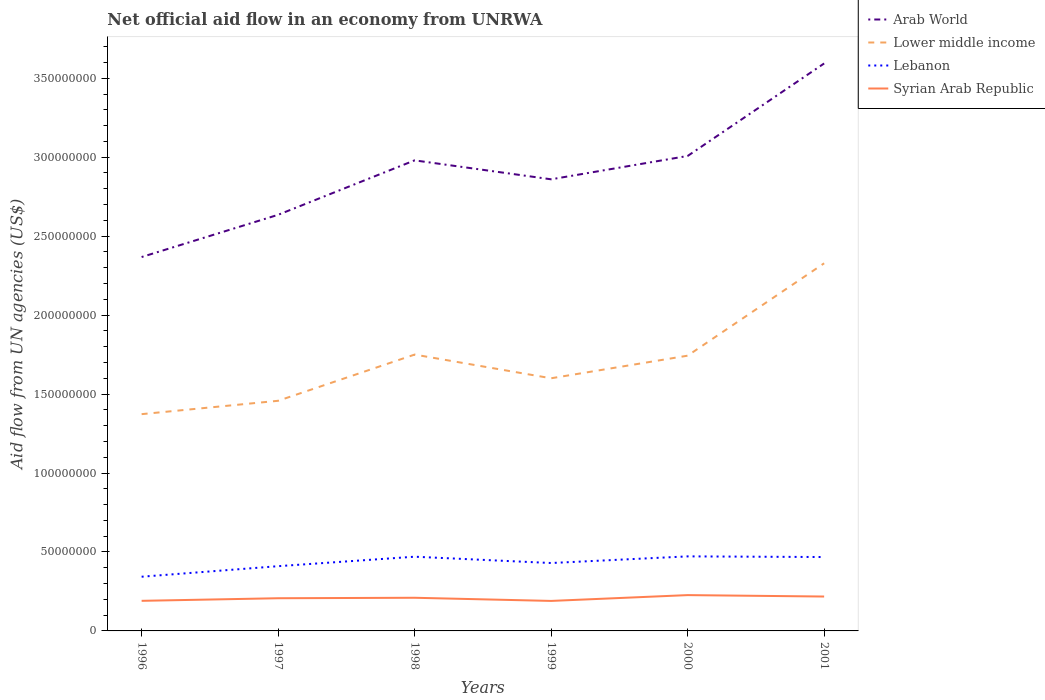How many different coloured lines are there?
Give a very brief answer. 4. Across all years, what is the maximum net official aid flow in Syrian Arab Republic?
Offer a terse response. 1.90e+07. In which year was the net official aid flow in Lower middle income maximum?
Offer a terse response. 1996. What is the total net official aid flow in Arab World in the graph?
Provide a short and direct response. -7.34e+07. What is the difference between the highest and the second highest net official aid flow in Lebanon?
Provide a succinct answer. 1.29e+07. What is the difference between the highest and the lowest net official aid flow in Syrian Arab Republic?
Provide a short and direct response. 3. Does the graph contain any zero values?
Provide a succinct answer. No. Does the graph contain grids?
Offer a terse response. No. How are the legend labels stacked?
Ensure brevity in your answer.  Vertical. What is the title of the graph?
Offer a very short reply. Net official aid flow in an economy from UNRWA. Does "Least developed countries" appear as one of the legend labels in the graph?
Your answer should be compact. No. What is the label or title of the Y-axis?
Offer a very short reply. Aid flow from UN agencies (US$). What is the Aid flow from UN agencies (US$) of Arab World in 1996?
Your answer should be compact. 2.37e+08. What is the Aid flow from UN agencies (US$) in Lower middle income in 1996?
Ensure brevity in your answer.  1.37e+08. What is the Aid flow from UN agencies (US$) of Lebanon in 1996?
Your answer should be compact. 3.43e+07. What is the Aid flow from UN agencies (US$) in Syrian Arab Republic in 1996?
Provide a succinct answer. 1.91e+07. What is the Aid flow from UN agencies (US$) of Arab World in 1997?
Offer a very short reply. 2.64e+08. What is the Aid flow from UN agencies (US$) of Lower middle income in 1997?
Your answer should be very brief. 1.46e+08. What is the Aid flow from UN agencies (US$) in Lebanon in 1997?
Keep it short and to the point. 4.10e+07. What is the Aid flow from UN agencies (US$) in Syrian Arab Republic in 1997?
Your response must be concise. 2.07e+07. What is the Aid flow from UN agencies (US$) of Arab World in 1998?
Your response must be concise. 2.98e+08. What is the Aid flow from UN agencies (US$) in Lower middle income in 1998?
Give a very brief answer. 1.75e+08. What is the Aid flow from UN agencies (US$) in Lebanon in 1998?
Your response must be concise. 4.70e+07. What is the Aid flow from UN agencies (US$) of Syrian Arab Republic in 1998?
Offer a terse response. 2.10e+07. What is the Aid flow from UN agencies (US$) in Arab World in 1999?
Ensure brevity in your answer.  2.86e+08. What is the Aid flow from UN agencies (US$) of Lower middle income in 1999?
Provide a succinct answer. 1.60e+08. What is the Aid flow from UN agencies (US$) of Lebanon in 1999?
Ensure brevity in your answer.  4.30e+07. What is the Aid flow from UN agencies (US$) of Syrian Arab Republic in 1999?
Your answer should be very brief. 1.90e+07. What is the Aid flow from UN agencies (US$) in Arab World in 2000?
Offer a very short reply. 3.01e+08. What is the Aid flow from UN agencies (US$) of Lower middle income in 2000?
Your answer should be very brief. 1.74e+08. What is the Aid flow from UN agencies (US$) in Lebanon in 2000?
Provide a succinct answer. 4.72e+07. What is the Aid flow from UN agencies (US$) of Syrian Arab Republic in 2000?
Make the answer very short. 2.27e+07. What is the Aid flow from UN agencies (US$) in Arab World in 2001?
Give a very brief answer. 3.59e+08. What is the Aid flow from UN agencies (US$) in Lower middle income in 2001?
Offer a very short reply. 2.33e+08. What is the Aid flow from UN agencies (US$) in Lebanon in 2001?
Ensure brevity in your answer.  4.68e+07. What is the Aid flow from UN agencies (US$) of Syrian Arab Republic in 2001?
Offer a terse response. 2.18e+07. Across all years, what is the maximum Aid flow from UN agencies (US$) in Arab World?
Keep it short and to the point. 3.59e+08. Across all years, what is the maximum Aid flow from UN agencies (US$) in Lower middle income?
Offer a terse response. 2.33e+08. Across all years, what is the maximum Aid flow from UN agencies (US$) in Lebanon?
Your response must be concise. 4.72e+07. Across all years, what is the maximum Aid flow from UN agencies (US$) of Syrian Arab Republic?
Provide a short and direct response. 2.27e+07. Across all years, what is the minimum Aid flow from UN agencies (US$) in Arab World?
Your answer should be very brief. 2.37e+08. Across all years, what is the minimum Aid flow from UN agencies (US$) in Lower middle income?
Offer a very short reply. 1.37e+08. Across all years, what is the minimum Aid flow from UN agencies (US$) in Lebanon?
Give a very brief answer. 3.43e+07. Across all years, what is the minimum Aid flow from UN agencies (US$) in Syrian Arab Republic?
Give a very brief answer. 1.90e+07. What is the total Aid flow from UN agencies (US$) in Arab World in the graph?
Give a very brief answer. 1.74e+09. What is the total Aid flow from UN agencies (US$) in Lower middle income in the graph?
Provide a short and direct response. 1.03e+09. What is the total Aid flow from UN agencies (US$) in Lebanon in the graph?
Ensure brevity in your answer.  2.59e+08. What is the total Aid flow from UN agencies (US$) of Syrian Arab Republic in the graph?
Provide a short and direct response. 1.24e+08. What is the difference between the Aid flow from UN agencies (US$) in Arab World in 1996 and that in 1997?
Make the answer very short. -2.67e+07. What is the difference between the Aid flow from UN agencies (US$) in Lower middle income in 1996 and that in 1997?
Your answer should be very brief. -8.46e+06. What is the difference between the Aid flow from UN agencies (US$) in Lebanon in 1996 and that in 1997?
Your answer should be compact. -6.67e+06. What is the difference between the Aid flow from UN agencies (US$) in Syrian Arab Republic in 1996 and that in 1997?
Ensure brevity in your answer.  -1.64e+06. What is the difference between the Aid flow from UN agencies (US$) in Arab World in 1996 and that in 1998?
Make the answer very short. -6.12e+07. What is the difference between the Aid flow from UN agencies (US$) of Lower middle income in 1996 and that in 1998?
Your response must be concise. -3.77e+07. What is the difference between the Aid flow from UN agencies (US$) of Lebanon in 1996 and that in 1998?
Your response must be concise. -1.27e+07. What is the difference between the Aid flow from UN agencies (US$) of Syrian Arab Republic in 1996 and that in 1998?
Provide a succinct answer. -1.94e+06. What is the difference between the Aid flow from UN agencies (US$) in Arab World in 1996 and that in 1999?
Your answer should be compact. -4.92e+07. What is the difference between the Aid flow from UN agencies (US$) of Lower middle income in 1996 and that in 1999?
Offer a terse response. -2.27e+07. What is the difference between the Aid flow from UN agencies (US$) in Lebanon in 1996 and that in 1999?
Your answer should be very brief. -8.67e+06. What is the difference between the Aid flow from UN agencies (US$) in Syrian Arab Republic in 1996 and that in 1999?
Make the answer very short. 6.00e+04. What is the difference between the Aid flow from UN agencies (US$) in Arab World in 1996 and that in 2000?
Your answer should be very brief. -6.40e+07. What is the difference between the Aid flow from UN agencies (US$) in Lower middle income in 1996 and that in 2000?
Provide a succinct answer. -3.70e+07. What is the difference between the Aid flow from UN agencies (US$) in Lebanon in 1996 and that in 2000?
Give a very brief answer. -1.29e+07. What is the difference between the Aid flow from UN agencies (US$) in Syrian Arab Republic in 1996 and that in 2000?
Provide a succinct answer. -3.62e+06. What is the difference between the Aid flow from UN agencies (US$) in Arab World in 1996 and that in 2001?
Your answer should be compact. -1.23e+08. What is the difference between the Aid flow from UN agencies (US$) in Lower middle income in 1996 and that in 2001?
Give a very brief answer. -9.55e+07. What is the difference between the Aid flow from UN agencies (US$) in Lebanon in 1996 and that in 2001?
Offer a terse response. -1.25e+07. What is the difference between the Aid flow from UN agencies (US$) of Syrian Arab Republic in 1996 and that in 2001?
Keep it short and to the point. -2.72e+06. What is the difference between the Aid flow from UN agencies (US$) in Arab World in 1997 and that in 1998?
Your answer should be very brief. -3.45e+07. What is the difference between the Aid flow from UN agencies (US$) of Lower middle income in 1997 and that in 1998?
Provide a succinct answer. -2.93e+07. What is the difference between the Aid flow from UN agencies (US$) in Lebanon in 1997 and that in 1998?
Your response must be concise. -6.00e+06. What is the difference between the Aid flow from UN agencies (US$) of Syrian Arab Republic in 1997 and that in 1998?
Offer a terse response. -3.00e+05. What is the difference between the Aid flow from UN agencies (US$) in Arab World in 1997 and that in 1999?
Provide a short and direct response. -2.25e+07. What is the difference between the Aid flow from UN agencies (US$) in Lower middle income in 1997 and that in 1999?
Offer a very short reply. -1.43e+07. What is the difference between the Aid flow from UN agencies (US$) of Lebanon in 1997 and that in 1999?
Keep it short and to the point. -2.00e+06. What is the difference between the Aid flow from UN agencies (US$) of Syrian Arab Republic in 1997 and that in 1999?
Your answer should be very brief. 1.70e+06. What is the difference between the Aid flow from UN agencies (US$) of Arab World in 1997 and that in 2000?
Provide a short and direct response. -3.73e+07. What is the difference between the Aid flow from UN agencies (US$) of Lower middle income in 1997 and that in 2000?
Provide a short and direct response. -2.86e+07. What is the difference between the Aid flow from UN agencies (US$) in Lebanon in 1997 and that in 2000?
Ensure brevity in your answer.  -6.21e+06. What is the difference between the Aid flow from UN agencies (US$) of Syrian Arab Republic in 1997 and that in 2000?
Ensure brevity in your answer.  -1.98e+06. What is the difference between the Aid flow from UN agencies (US$) of Arab World in 1997 and that in 2001?
Make the answer very short. -9.58e+07. What is the difference between the Aid flow from UN agencies (US$) of Lower middle income in 1997 and that in 2001?
Give a very brief answer. -8.71e+07. What is the difference between the Aid flow from UN agencies (US$) in Lebanon in 1997 and that in 2001?
Offer a very short reply. -5.79e+06. What is the difference between the Aid flow from UN agencies (US$) of Syrian Arab Republic in 1997 and that in 2001?
Your answer should be compact. -1.08e+06. What is the difference between the Aid flow from UN agencies (US$) in Arab World in 1998 and that in 1999?
Make the answer very short. 1.20e+07. What is the difference between the Aid flow from UN agencies (US$) in Lower middle income in 1998 and that in 1999?
Provide a succinct answer. 1.50e+07. What is the difference between the Aid flow from UN agencies (US$) of Syrian Arab Republic in 1998 and that in 1999?
Provide a short and direct response. 2.00e+06. What is the difference between the Aid flow from UN agencies (US$) of Arab World in 1998 and that in 2000?
Provide a short and direct response. -2.78e+06. What is the difference between the Aid flow from UN agencies (US$) of Lower middle income in 1998 and that in 2000?
Your response must be concise. 6.90e+05. What is the difference between the Aid flow from UN agencies (US$) of Lebanon in 1998 and that in 2000?
Make the answer very short. -2.10e+05. What is the difference between the Aid flow from UN agencies (US$) in Syrian Arab Republic in 1998 and that in 2000?
Provide a short and direct response. -1.68e+06. What is the difference between the Aid flow from UN agencies (US$) in Arab World in 1998 and that in 2001?
Your answer should be compact. -6.14e+07. What is the difference between the Aid flow from UN agencies (US$) in Lower middle income in 1998 and that in 2001?
Make the answer very short. -5.78e+07. What is the difference between the Aid flow from UN agencies (US$) of Lebanon in 1998 and that in 2001?
Ensure brevity in your answer.  2.10e+05. What is the difference between the Aid flow from UN agencies (US$) in Syrian Arab Republic in 1998 and that in 2001?
Provide a short and direct response. -7.80e+05. What is the difference between the Aid flow from UN agencies (US$) of Arab World in 1999 and that in 2000?
Offer a terse response. -1.48e+07. What is the difference between the Aid flow from UN agencies (US$) of Lower middle income in 1999 and that in 2000?
Give a very brief answer. -1.43e+07. What is the difference between the Aid flow from UN agencies (US$) of Lebanon in 1999 and that in 2000?
Your answer should be very brief. -4.21e+06. What is the difference between the Aid flow from UN agencies (US$) of Syrian Arab Republic in 1999 and that in 2000?
Keep it short and to the point. -3.68e+06. What is the difference between the Aid flow from UN agencies (US$) of Arab World in 1999 and that in 2001?
Offer a very short reply. -7.34e+07. What is the difference between the Aid flow from UN agencies (US$) in Lower middle income in 1999 and that in 2001?
Give a very brief answer. -7.28e+07. What is the difference between the Aid flow from UN agencies (US$) of Lebanon in 1999 and that in 2001?
Provide a succinct answer. -3.79e+06. What is the difference between the Aid flow from UN agencies (US$) in Syrian Arab Republic in 1999 and that in 2001?
Your response must be concise. -2.78e+06. What is the difference between the Aid flow from UN agencies (US$) of Arab World in 2000 and that in 2001?
Your response must be concise. -5.86e+07. What is the difference between the Aid flow from UN agencies (US$) in Lower middle income in 2000 and that in 2001?
Offer a very short reply. -5.85e+07. What is the difference between the Aid flow from UN agencies (US$) in Arab World in 1996 and the Aid flow from UN agencies (US$) in Lower middle income in 1997?
Offer a very short reply. 9.10e+07. What is the difference between the Aid flow from UN agencies (US$) in Arab World in 1996 and the Aid flow from UN agencies (US$) in Lebanon in 1997?
Make the answer very short. 1.96e+08. What is the difference between the Aid flow from UN agencies (US$) in Arab World in 1996 and the Aid flow from UN agencies (US$) in Syrian Arab Republic in 1997?
Keep it short and to the point. 2.16e+08. What is the difference between the Aid flow from UN agencies (US$) of Lower middle income in 1996 and the Aid flow from UN agencies (US$) of Lebanon in 1997?
Keep it short and to the point. 9.63e+07. What is the difference between the Aid flow from UN agencies (US$) in Lower middle income in 1996 and the Aid flow from UN agencies (US$) in Syrian Arab Republic in 1997?
Ensure brevity in your answer.  1.17e+08. What is the difference between the Aid flow from UN agencies (US$) of Lebanon in 1996 and the Aid flow from UN agencies (US$) of Syrian Arab Republic in 1997?
Give a very brief answer. 1.36e+07. What is the difference between the Aid flow from UN agencies (US$) in Arab World in 1996 and the Aid flow from UN agencies (US$) in Lower middle income in 1998?
Make the answer very short. 6.18e+07. What is the difference between the Aid flow from UN agencies (US$) of Arab World in 1996 and the Aid flow from UN agencies (US$) of Lebanon in 1998?
Your answer should be very brief. 1.90e+08. What is the difference between the Aid flow from UN agencies (US$) of Arab World in 1996 and the Aid flow from UN agencies (US$) of Syrian Arab Republic in 1998?
Make the answer very short. 2.16e+08. What is the difference between the Aid flow from UN agencies (US$) in Lower middle income in 1996 and the Aid flow from UN agencies (US$) in Lebanon in 1998?
Offer a terse response. 9.03e+07. What is the difference between the Aid flow from UN agencies (US$) of Lower middle income in 1996 and the Aid flow from UN agencies (US$) of Syrian Arab Republic in 1998?
Keep it short and to the point. 1.16e+08. What is the difference between the Aid flow from UN agencies (US$) of Lebanon in 1996 and the Aid flow from UN agencies (US$) of Syrian Arab Republic in 1998?
Your answer should be very brief. 1.33e+07. What is the difference between the Aid flow from UN agencies (US$) of Arab World in 1996 and the Aid flow from UN agencies (US$) of Lower middle income in 1999?
Provide a short and direct response. 7.68e+07. What is the difference between the Aid flow from UN agencies (US$) in Arab World in 1996 and the Aid flow from UN agencies (US$) in Lebanon in 1999?
Make the answer very short. 1.94e+08. What is the difference between the Aid flow from UN agencies (US$) of Arab World in 1996 and the Aid flow from UN agencies (US$) of Syrian Arab Republic in 1999?
Provide a short and direct response. 2.18e+08. What is the difference between the Aid flow from UN agencies (US$) in Lower middle income in 1996 and the Aid flow from UN agencies (US$) in Lebanon in 1999?
Your answer should be compact. 9.43e+07. What is the difference between the Aid flow from UN agencies (US$) of Lower middle income in 1996 and the Aid flow from UN agencies (US$) of Syrian Arab Republic in 1999?
Ensure brevity in your answer.  1.18e+08. What is the difference between the Aid flow from UN agencies (US$) in Lebanon in 1996 and the Aid flow from UN agencies (US$) in Syrian Arab Republic in 1999?
Make the answer very short. 1.53e+07. What is the difference between the Aid flow from UN agencies (US$) in Arab World in 1996 and the Aid flow from UN agencies (US$) in Lower middle income in 2000?
Provide a succinct answer. 6.25e+07. What is the difference between the Aid flow from UN agencies (US$) of Arab World in 1996 and the Aid flow from UN agencies (US$) of Lebanon in 2000?
Offer a terse response. 1.90e+08. What is the difference between the Aid flow from UN agencies (US$) in Arab World in 1996 and the Aid flow from UN agencies (US$) in Syrian Arab Republic in 2000?
Provide a succinct answer. 2.14e+08. What is the difference between the Aid flow from UN agencies (US$) in Lower middle income in 1996 and the Aid flow from UN agencies (US$) in Lebanon in 2000?
Give a very brief answer. 9.01e+07. What is the difference between the Aid flow from UN agencies (US$) of Lower middle income in 1996 and the Aid flow from UN agencies (US$) of Syrian Arab Republic in 2000?
Provide a succinct answer. 1.15e+08. What is the difference between the Aid flow from UN agencies (US$) of Lebanon in 1996 and the Aid flow from UN agencies (US$) of Syrian Arab Republic in 2000?
Offer a very short reply. 1.16e+07. What is the difference between the Aid flow from UN agencies (US$) of Arab World in 1996 and the Aid flow from UN agencies (US$) of Lower middle income in 2001?
Ensure brevity in your answer.  3.97e+06. What is the difference between the Aid flow from UN agencies (US$) in Arab World in 1996 and the Aid flow from UN agencies (US$) in Lebanon in 2001?
Offer a terse response. 1.90e+08. What is the difference between the Aid flow from UN agencies (US$) of Arab World in 1996 and the Aid flow from UN agencies (US$) of Syrian Arab Republic in 2001?
Offer a terse response. 2.15e+08. What is the difference between the Aid flow from UN agencies (US$) in Lower middle income in 1996 and the Aid flow from UN agencies (US$) in Lebanon in 2001?
Your response must be concise. 9.05e+07. What is the difference between the Aid flow from UN agencies (US$) of Lower middle income in 1996 and the Aid flow from UN agencies (US$) of Syrian Arab Republic in 2001?
Provide a succinct answer. 1.16e+08. What is the difference between the Aid flow from UN agencies (US$) in Lebanon in 1996 and the Aid flow from UN agencies (US$) in Syrian Arab Republic in 2001?
Your answer should be compact. 1.26e+07. What is the difference between the Aid flow from UN agencies (US$) in Arab World in 1997 and the Aid flow from UN agencies (US$) in Lower middle income in 1998?
Offer a very short reply. 8.85e+07. What is the difference between the Aid flow from UN agencies (US$) in Arab World in 1997 and the Aid flow from UN agencies (US$) in Lebanon in 1998?
Your response must be concise. 2.17e+08. What is the difference between the Aid flow from UN agencies (US$) in Arab World in 1997 and the Aid flow from UN agencies (US$) in Syrian Arab Republic in 1998?
Provide a succinct answer. 2.43e+08. What is the difference between the Aid flow from UN agencies (US$) of Lower middle income in 1997 and the Aid flow from UN agencies (US$) of Lebanon in 1998?
Provide a short and direct response. 9.87e+07. What is the difference between the Aid flow from UN agencies (US$) of Lower middle income in 1997 and the Aid flow from UN agencies (US$) of Syrian Arab Republic in 1998?
Give a very brief answer. 1.25e+08. What is the difference between the Aid flow from UN agencies (US$) in Lebanon in 1997 and the Aid flow from UN agencies (US$) in Syrian Arab Republic in 1998?
Your response must be concise. 2.00e+07. What is the difference between the Aid flow from UN agencies (US$) in Arab World in 1997 and the Aid flow from UN agencies (US$) in Lower middle income in 1999?
Provide a short and direct response. 1.04e+08. What is the difference between the Aid flow from UN agencies (US$) in Arab World in 1997 and the Aid flow from UN agencies (US$) in Lebanon in 1999?
Provide a succinct answer. 2.21e+08. What is the difference between the Aid flow from UN agencies (US$) in Arab World in 1997 and the Aid flow from UN agencies (US$) in Syrian Arab Republic in 1999?
Your answer should be compact. 2.45e+08. What is the difference between the Aid flow from UN agencies (US$) in Lower middle income in 1997 and the Aid flow from UN agencies (US$) in Lebanon in 1999?
Offer a terse response. 1.03e+08. What is the difference between the Aid flow from UN agencies (US$) in Lower middle income in 1997 and the Aid flow from UN agencies (US$) in Syrian Arab Republic in 1999?
Give a very brief answer. 1.27e+08. What is the difference between the Aid flow from UN agencies (US$) of Lebanon in 1997 and the Aid flow from UN agencies (US$) of Syrian Arab Republic in 1999?
Offer a very short reply. 2.20e+07. What is the difference between the Aid flow from UN agencies (US$) in Arab World in 1997 and the Aid flow from UN agencies (US$) in Lower middle income in 2000?
Your answer should be compact. 8.92e+07. What is the difference between the Aid flow from UN agencies (US$) in Arab World in 1997 and the Aid flow from UN agencies (US$) in Lebanon in 2000?
Ensure brevity in your answer.  2.16e+08. What is the difference between the Aid flow from UN agencies (US$) in Arab World in 1997 and the Aid flow from UN agencies (US$) in Syrian Arab Republic in 2000?
Offer a very short reply. 2.41e+08. What is the difference between the Aid flow from UN agencies (US$) in Lower middle income in 1997 and the Aid flow from UN agencies (US$) in Lebanon in 2000?
Keep it short and to the point. 9.85e+07. What is the difference between the Aid flow from UN agencies (US$) of Lower middle income in 1997 and the Aid flow from UN agencies (US$) of Syrian Arab Republic in 2000?
Your answer should be very brief. 1.23e+08. What is the difference between the Aid flow from UN agencies (US$) in Lebanon in 1997 and the Aid flow from UN agencies (US$) in Syrian Arab Republic in 2000?
Keep it short and to the point. 1.83e+07. What is the difference between the Aid flow from UN agencies (US$) in Arab World in 1997 and the Aid flow from UN agencies (US$) in Lower middle income in 2001?
Your answer should be very brief. 3.07e+07. What is the difference between the Aid flow from UN agencies (US$) in Arab World in 1997 and the Aid flow from UN agencies (US$) in Lebanon in 2001?
Ensure brevity in your answer.  2.17e+08. What is the difference between the Aid flow from UN agencies (US$) of Arab World in 1997 and the Aid flow from UN agencies (US$) of Syrian Arab Republic in 2001?
Provide a short and direct response. 2.42e+08. What is the difference between the Aid flow from UN agencies (US$) of Lower middle income in 1997 and the Aid flow from UN agencies (US$) of Lebanon in 2001?
Ensure brevity in your answer.  9.90e+07. What is the difference between the Aid flow from UN agencies (US$) of Lower middle income in 1997 and the Aid flow from UN agencies (US$) of Syrian Arab Republic in 2001?
Your response must be concise. 1.24e+08. What is the difference between the Aid flow from UN agencies (US$) of Lebanon in 1997 and the Aid flow from UN agencies (US$) of Syrian Arab Republic in 2001?
Offer a very short reply. 1.92e+07. What is the difference between the Aid flow from UN agencies (US$) in Arab World in 1998 and the Aid flow from UN agencies (US$) in Lower middle income in 1999?
Offer a very short reply. 1.38e+08. What is the difference between the Aid flow from UN agencies (US$) in Arab World in 1998 and the Aid flow from UN agencies (US$) in Lebanon in 1999?
Keep it short and to the point. 2.55e+08. What is the difference between the Aid flow from UN agencies (US$) in Arab World in 1998 and the Aid flow from UN agencies (US$) in Syrian Arab Republic in 1999?
Provide a succinct answer. 2.79e+08. What is the difference between the Aid flow from UN agencies (US$) of Lower middle income in 1998 and the Aid flow from UN agencies (US$) of Lebanon in 1999?
Your answer should be compact. 1.32e+08. What is the difference between the Aid flow from UN agencies (US$) of Lower middle income in 1998 and the Aid flow from UN agencies (US$) of Syrian Arab Republic in 1999?
Provide a succinct answer. 1.56e+08. What is the difference between the Aid flow from UN agencies (US$) in Lebanon in 1998 and the Aid flow from UN agencies (US$) in Syrian Arab Republic in 1999?
Provide a short and direct response. 2.80e+07. What is the difference between the Aid flow from UN agencies (US$) of Arab World in 1998 and the Aid flow from UN agencies (US$) of Lower middle income in 2000?
Provide a short and direct response. 1.24e+08. What is the difference between the Aid flow from UN agencies (US$) of Arab World in 1998 and the Aid flow from UN agencies (US$) of Lebanon in 2000?
Make the answer very short. 2.51e+08. What is the difference between the Aid flow from UN agencies (US$) of Arab World in 1998 and the Aid flow from UN agencies (US$) of Syrian Arab Republic in 2000?
Provide a succinct answer. 2.75e+08. What is the difference between the Aid flow from UN agencies (US$) in Lower middle income in 1998 and the Aid flow from UN agencies (US$) in Lebanon in 2000?
Your response must be concise. 1.28e+08. What is the difference between the Aid flow from UN agencies (US$) of Lower middle income in 1998 and the Aid flow from UN agencies (US$) of Syrian Arab Republic in 2000?
Give a very brief answer. 1.52e+08. What is the difference between the Aid flow from UN agencies (US$) in Lebanon in 1998 and the Aid flow from UN agencies (US$) in Syrian Arab Republic in 2000?
Your response must be concise. 2.43e+07. What is the difference between the Aid flow from UN agencies (US$) in Arab World in 1998 and the Aid flow from UN agencies (US$) in Lower middle income in 2001?
Provide a succinct answer. 6.52e+07. What is the difference between the Aid flow from UN agencies (US$) in Arab World in 1998 and the Aid flow from UN agencies (US$) in Lebanon in 2001?
Your response must be concise. 2.51e+08. What is the difference between the Aid flow from UN agencies (US$) of Arab World in 1998 and the Aid flow from UN agencies (US$) of Syrian Arab Republic in 2001?
Keep it short and to the point. 2.76e+08. What is the difference between the Aid flow from UN agencies (US$) in Lower middle income in 1998 and the Aid flow from UN agencies (US$) in Lebanon in 2001?
Your response must be concise. 1.28e+08. What is the difference between the Aid flow from UN agencies (US$) of Lower middle income in 1998 and the Aid flow from UN agencies (US$) of Syrian Arab Republic in 2001?
Provide a succinct answer. 1.53e+08. What is the difference between the Aid flow from UN agencies (US$) in Lebanon in 1998 and the Aid flow from UN agencies (US$) in Syrian Arab Republic in 2001?
Your answer should be compact. 2.52e+07. What is the difference between the Aid flow from UN agencies (US$) in Arab World in 1999 and the Aid flow from UN agencies (US$) in Lower middle income in 2000?
Give a very brief answer. 1.12e+08. What is the difference between the Aid flow from UN agencies (US$) in Arab World in 1999 and the Aid flow from UN agencies (US$) in Lebanon in 2000?
Provide a succinct answer. 2.39e+08. What is the difference between the Aid flow from UN agencies (US$) in Arab World in 1999 and the Aid flow from UN agencies (US$) in Syrian Arab Republic in 2000?
Provide a short and direct response. 2.63e+08. What is the difference between the Aid flow from UN agencies (US$) of Lower middle income in 1999 and the Aid flow from UN agencies (US$) of Lebanon in 2000?
Your response must be concise. 1.13e+08. What is the difference between the Aid flow from UN agencies (US$) in Lower middle income in 1999 and the Aid flow from UN agencies (US$) in Syrian Arab Republic in 2000?
Provide a short and direct response. 1.37e+08. What is the difference between the Aid flow from UN agencies (US$) in Lebanon in 1999 and the Aid flow from UN agencies (US$) in Syrian Arab Republic in 2000?
Provide a succinct answer. 2.03e+07. What is the difference between the Aid flow from UN agencies (US$) in Arab World in 1999 and the Aid flow from UN agencies (US$) in Lower middle income in 2001?
Your answer should be very brief. 5.32e+07. What is the difference between the Aid flow from UN agencies (US$) in Arab World in 1999 and the Aid flow from UN agencies (US$) in Lebanon in 2001?
Keep it short and to the point. 2.39e+08. What is the difference between the Aid flow from UN agencies (US$) in Arab World in 1999 and the Aid flow from UN agencies (US$) in Syrian Arab Republic in 2001?
Provide a short and direct response. 2.64e+08. What is the difference between the Aid flow from UN agencies (US$) in Lower middle income in 1999 and the Aid flow from UN agencies (US$) in Lebanon in 2001?
Offer a very short reply. 1.13e+08. What is the difference between the Aid flow from UN agencies (US$) of Lower middle income in 1999 and the Aid flow from UN agencies (US$) of Syrian Arab Republic in 2001?
Keep it short and to the point. 1.38e+08. What is the difference between the Aid flow from UN agencies (US$) in Lebanon in 1999 and the Aid flow from UN agencies (US$) in Syrian Arab Republic in 2001?
Offer a terse response. 2.12e+07. What is the difference between the Aid flow from UN agencies (US$) in Arab World in 2000 and the Aid flow from UN agencies (US$) in Lower middle income in 2001?
Offer a terse response. 6.80e+07. What is the difference between the Aid flow from UN agencies (US$) of Arab World in 2000 and the Aid flow from UN agencies (US$) of Lebanon in 2001?
Your answer should be very brief. 2.54e+08. What is the difference between the Aid flow from UN agencies (US$) of Arab World in 2000 and the Aid flow from UN agencies (US$) of Syrian Arab Republic in 2001?
Provide a succinct answer. 2.79e+08. What is the difference between the Aid flow from UN agencies (US$) in Lower middle income in 2000 and the Aid flow from UN agencies (US$) in Lebanon in 2001?
Your answer should be compact. 1.28e+08. What is the difference between the Aid flow from UN agencies (US$) of Lower middle income in 2000 and the Aid flow from UN agencies (US$) of Syrian Arab Republic in 2001?
Your answer should be very brief. 1.53e+08. What is the difference between the Aid flow from UN agencies (US$) in Lebanon in 2000 and the Aid flow from UN agencies (US$) in Syrian Arab Republic in 2001?
Your answer should be compact. 2.54e+07. What is the average Aid flow from UN agencies (US$) of Arab World per year?
Make the answer very short. 2.91e+08. What is the average Aid flow from UN agencies (US$) in Lower middle income per year?
Make the answer very short. 1.71e+08. What is the average Aid flow from UN agencies (US$) in Lebanon per year?
Provide a succinct answer. 4.32e+07. What is the average Aid flow from UN agencies (US$) of Syrian Arab Republic per year?
Your answer should be very brief. 2.07e+07. In the year 1996, what is the difference between the Aid flow from UN agencies (US$) of Arab World and Aid flow from UN agencies (US$) of Lower middle income?
Offer a very short reply. 9.95e+07. In the year 1996, what is the difference between the Aid flow from UN agencies (US$) in Arab World and Aid flow from UN agencies (US$) in Lebanon?
Give a very brief answer. 2.02e+08. In the year 1996, what is the difference between the Aid flow from UN agencies (US$) in Arab World and Aid flow from UN agencies (US$) in Syrian Arab Republic?
Make the answer very short. 2.18e+08. In the year 1996, what is the difference between the Aid flow from UN agencies (US$) of Lower middle income and Aid flow from UN agencies (US$) of Lebanon?
Offer a very short reply. 1.03e+08. In the year 1996, what is the difference between the Aid flow from UN agencies (US$) in Lower middle income and Aid flow from UN agencies (US$) in Syrian Arab Republic?
Keep it short and to the point. 1.18e+08. In the year 1996, what is the difference between the Aid flow from UN agencies (US$) of Lebanon and Aid flow from UN agencies (US$) of Syrian Arab Republic?
Give a very brief answer. 1.53e+07. In the year 1997, what is the difference between the Aid flow from UN agencies (US$) in Arab World and Aid flow from UN agencies (US$) in Lower middle income?
Your response must be concise. 1.18e+08. In the year 1997, what is the difference between the Aid flow from UN agencies (US$) in Arab World and Aid flow from UN agencies (US$) in Lebanon?
Give a very brief answer. 2.23e+08. In the year 1997, what is the difference between the Aid flow from UN agencies (US$) in Arab World and Aid flow from UN agencies (US$) in Syrian Arab Republic?
Ensure brevity in your answer.  2.43e+08. In the year 1997, what is the difference between the Aid flow from UN agencies (US$) in Lower middle income and Aid flow from UN agencies (US$) in Lebanon?
Make the answer very short. 1.05e+08. In the year 1997, what is the difference between the Aid flow from UN agencies (US$) in Lower middle income and Aid flow from UN agencies (US$) in Syrian Arab Republic?
Your answer should be very brief. 1.25e+08. In the year 1997, what is the difference between the Aid flow from UN agencies (US$) of Lebanon and Aid flow from UN agencies (US$) of Syrian Arab Republic?
Ensure brevity in your answer.  2.03e+07. In the year 1998, what is the difference between the Aid flow from UN agencies (US$) of Arab World and Aid flow from UN agencies (US$) of Lower middle income?
Offer a terse response. 1.23e+08. In the year 1998, what is the difference between the Aid flow from UN agencies (US$) of Arab World and Aid flow from UN agencies (US$) of Lebanon?
Make the answer very short. 2.51e+08. In the year 1998, what is the difference between the Aid flow from UN agencies (US$) in Arab World and Aid flow from UN agencies (US$) in Syrian Arab Republic?
Keep it short and to the point. 2.77e+08. In the year 1998, what is the difference between the Aid flow from UN agencies (US$) of Lower middle income and Aid flow from UN agencies (US$) of Lebanon?
Offer a terse response. 1.28e+08. In the year 1998, what is the difference between the Aid flow from UN agencies (US$) in Lower middle income and Aid flow from UN agencies (US$) in Syrian Arab Republic?
Keep it short and to the point. 1.54e+08. In the year 1998, what is the difference between the Aid flow from UN agencies (US$) in Lebanon and Aid flow from UN agencies (US$) in Syrian Arab Republic?
Your answer should be compact. 2.60e+07. In the year 1999, what is the difference between the Aid flow from UN agencies (US$) in Arab World and Aid flow from UN agencies (US$) in Lower middle income?
Provide a succinct answer. 1.26e+08. In the year 1999, what is the difference between the Aid flow from UN agencies (US$) in Arab World and Aid flow from UN agencies (US$) in Lebanon?
Keep it short and to the point. 2.43e+08. In the year 1999, what is the difference between the Aid flow from UN agencies (US$) in Arab World and Aid flow from UN agencies (US$) in Syrian Arab Republic?
Provide a short and direct response. 2.67e+08. In the year 1999, what is the difference between the Aid flow from UN agencies (US$) in Lower middle income and Aid flow from UN agencies (US$) in Lebanon?
Keep it short and to the point. 1.17e+08. In the year 1999, what is the difference between the Aid flow from UN agencies (US$) in Lower middle income and Aid flow from UN agencies (US$) in Syrian Arab Republic?
Provide a succinct answer. 1.41e+08. In the year 1999, what is the difference between the Aid flow from UN agencies (US$) of Lebanon and Aid flow from UN agencies (US$) of Syrian Arab Republic?
Your answer should be very brief. 2.40e+07. In the year 2000, what is the difference between the Aid flow from UN agencies (US$) of Arab World and Aid flow from UN agencies (US$) of Lower middle income?
Your response must be concise. 1.26e+08. In the year 2000, what is the difference between the Aid flow from UN agencies (US$) in Arab World and Aid flow from UN agencies (US$) in Lebanon?
Offer a terse response. 2.54e+08. In the year 2000, what is the difference between the Aid flow from UN agencies (US$) in Arab World and Aid flow from UN agencies (US$) in Syrian Arab Republic?
Provide a succinct answer. 2.78e+08. In the year 2000, what is the difference between the Aid flow from UN agencies (US$) of Lower middle income and Aid flow from UN agencies (US$) of Lebanon?
Give a very brief answer. 1.27e+08. In the year 2000, what is the difference between the Aid flow from UN agencies (US$) in Lower middle income and Aid flow from UN agencies (US$) in Syrian Arab Republic?
Give a very brief answer. 1.52e+08. In the year 2000, what is the difference between the Aid flow from UN agencies (US$) in Lebanon and Aid flow from UN agencies (US$) in Syrian Arab Republic?
Your answer should be very brief. 2.45e+07. In the year 2001, what is the difference between the Aid flow from UN agencies (US$) in Arab World and Aid flow from UN agencies (US$) in Lower middle income?
Provide a short and direct response. 1.27e+08. In the year 2001, what is the difference between the Aid flow from UN agencies (US$) of Arab World and Aid flow from UN agencies (US$) of Lebanon?
Keep it short and to the point. 3.13e+08. In the year 2001, what is the difference between the Aid flow from UN agencies (US$) in Arab World and Aid flow from UN agencies (US$) in Syrian Arab Republic?
Your response must be concise. 3.38e+08. In the year 2001, what is the difference between the Aid flow from UN agencies (US$) in Lower middle income and Aid flow from UN agencies (US$) in Lebanon?
Make the answer very short. 1.86e+08. In the year 2001, what is the difference between the Aid flow from UN agencies (US$) in Lower middle income and Aid flow from UN agencies (US$) in Syrian Arab Republic?
Provide a short and direct response. 2.11e+08. In the year 2001, what is the difference between the Aid flow from UN agencies (US$) in Lebanon and Aid flow from UN agencies (US$) in Syrian Arab Republic?
Ensure brevity in your answer.  2.50e+07. What is the ratio of the Aid flow from UN agencies (US$) of Arab World in 1996 to that in 1997?
Provide a succinct answer. 0.9. What is the ratio of the Aid flow from UN agencies (US$) of Lower middle income in 1996 to that in 1997?
Make the answer very short. 0.94. What is the ratio of the Aid flow from UN agencies (US$) in Lebanon in 1996 to that in 1997?
Give a very brief answer. 0.84. What is the ratio of the Aid flow from UN agencies (US$) of Syrian Arab Republic in 1996 to that in 1997?
Keep it short and to the point. 0.92. What is the ratio of the Aid flow from UN agencies (US$) in Arab World in 1996 to that in 1998?
Your response must be concise. 0.79. What is the ratio of the Aid flow from UN agencies (US$) in Lower middle income in 1996 to that in 1998?
Give a very brief answer. 0.78. What is the ratio of the Aid flow from UN agencies (US$) in Lebanon in 1996 to that in 1998?
Ensure brevity in your answer.  0.73. What is the ratio of the Aid flow from UN agencies (US$) in Syrian Arab Republic in 1996 to that in 1998?
Your answer should be compact. 0.91. What is the ratio of the Aid flow from UN agencies (US$) in Arab World in 1996 to that in 1999?
Make the answer very short. 0.83. What is the ratio of the Aid flow from UN agencies (US$) of Lower middle income in 1996 to that in 1999?
Offer a very short reply. 0.86. What is the ratio of the Aid flow from UN agencies (US$) of Lebanon in 1996 to that in 1999?
Provide a short and direct response. 0.8. What is the ratio of the Aid flow from UN agencies (US$) of Syrian Arab Republic in 1996 to that in 1999?
Keep it short and to the point. 1. What is the ratio of the Aid flow from UN agencies (US$) in Arab World in 1996 to that in 2000?
Your response must be concise. 0.79. What is the ratio of the Aid flow from UN agencies (US$) in Lower middle income in 1996 to that in 2000?
Your answer should be very brief. 0.79. What is the ratio of the Aid flow from UN agencies (US$) of Lebanon in 1996 to that in 2000?
Ensure brevity in your answer.  0.73. What is the ratio of the Aid flow from UN agencies (US$) of Syrian Arab Republic in 1996 to that in 2000?
Provide a short and direct response. 0.84. What is the ratio of the Aid flow from UN agencies (US$) in Arab World in 1996 to that in 2001?
Make the answer very short. 0.66. What is the ratio of the Aid flow from UN agencies (US$) in Lower middle income in 1996 to that in 2001?
Offer a terse response. 0.59. What is the ratio of the Aid flow from UN agencies (US$) of Lebanon in 1996 to that in 2001?
Offer a terse response. 0.73. What is the ratio of the Aid flow from UN agencies (US$) of Syrian Arab Republic in 1996 to that in 2001?
Offer a terse response. 0.88. What is the ratio of the Aid flow from UN agencies (US$) of Arab World in 1997 to that in 1998?
Provide a succinct answer. 0.88. What is the ratio of the Aid flow from UN agencies (US$) in Lower middle income in 1997 to that in 1998?
Keep it short and to the point. 0.83. What is the ratio of the Aid flow from UN agencies (US$) of Lebanon in 1997 to that in 1998?
Give a very brief answer. 0.87. What is the ratio of the Aid flow from UN agencies (US$) in Syrian Arab Republic in 1997 to that in 1998?
Your answer should be compact. 0.99. What is the ratio of the Aid flow from UN agencies (US$) in Arab World in 1997 to that in 1999?
Offer a terse response. 0.92. What is the ratio of the Aid flow from UN agencies (US$) in Lower middle income in 1997 to that in 1999?
Provide a succinct answer. 0.91. What is the ratio of the Aid flow from UN agencies (US$) of Lebanon in 1997 to that in 1999?
Offer a very short reply. 0.95. What is the ratio of the Aid flow from UN agencies (US$) of Syrian Arab Republic in 1997 to that in 1999?
Offer a terse response. 1.09. What is the ratio of the Aid flow from UN agencies (US$) of Arab World in 1997 to that in 2000?
Give a very brief answer. 0.88. What is the ratio of the Aid flow from UN agencies (US$) of Lower middle income in 1997 to that in 2000?
Give a very brief answer. 0.84. What is the ratio of the Aid flow from UN agencies (US$) of Lebanon in 1997 to that in 2000?
Ensure brevity in your answer.  0.87. What is the ratio of the Aid flow from UN agencies (US$) of Syrian Arab Republic in 1997 to that in 2000?
Your response must be concise. 0.91. What is the ratio of the Aid flow from UN agencies (US$) in Arab World in 1997 to that in 2001?
Offer a very short reply. 0.73. What is the ratio of the Aid flow from UN agencies (US$) of Lower middle income in 1997 to that in 2001?
Keep it short and to the point. 0.63. What is the ratio of the Aid flow from UN agencies (US$) in Lebanon in 1997 to that in 2001?
Your answer should be very brief. 0.88. What is the ratio of the Aid flow from UN agencies (US$) of Syrian Arab Republic in 1997 to that in 2001?
Give a very brief answer. 0.95. What is the ratio of the Aid flow from UN agencies (US$) in Arab World in 1998 to that in 1999?
Provide a short and direct response. 1.04. What is the ratio of the Aid flow from UN agencies (US$) of Lower middle income in 1998 to that in 1999?
Your response must be concise. 1.09. What is the ratio of the Aid flow from UN agencies (US$) of Lebanon in 1998 to that in 1999?
Your response must be concise. 1.09. What is the ratio of the Aid flow from UN agencies (US$) of Syrian Arab Republic in 1998 to that in 1999?
Provide a short and direct response. 1.11. What is the ratio of the Aid flow from UN agencies (US$) in Syrian Arab Republic in 1998 to that in 2000?
Your response must be concise. 0.93. What is the ratio of the Aid flow from UN agencies (US$) in Arab World in 1998 to that in 2001?
Provide a succinct answer. 0.83. What is the ratio of the Aid flow from UN agencies (US$) of Lower middle income in 1998 to that in 2001?
Provide a short and direct response. 0.75. What is the ratio of the Aid flow from UN agencies (US$) in Syrian Arab Republic in 1998 to that in 2001?
Your answer should be compact. 0.96. What is the ratio of the Aid flow from UN agencies (US$) in Arab World in 1999 to that in 2000?
Give a very brief answer. 0.95. What is the ratio of the Aid flow from UN agencies (US$) of Lower middle income in 1999 to that in 2000?
Your response must be concise. 0.92. What is the ratio of the Aid flow from UN agencies (US$) in Lebanon in 1999 to that in 2000?
Make the answer very short. 0.91. What is the ratio of the Aid flow from UN agencies (US$) of Syrian Arab Republic in 1999 to that in 2000?
Offer a very short reply. 0.84. What is the ratio of the Aid flow from UN agencies (US$) of Arab World in 1999 to that in 2001?
Ensure brevity in your answer.  0.8. What is the ratio of the Aid flow from UN agencies (US$) of Lower middle income in 1999 to that in 2001?
Your answer should be compact. 0.69. What is the ratio of the Aid flow from UN agencies (US$) in Lebanon in 1999 to that in 2001?
Provide a succinct answer. 0.92. What is the ratio of the Aid flow from UN agencies (US$) in Syrian Arab Republic in 1999 to that in 2001?
Offer a very short reply. 0.87. What is the ratio of the Aid flow from UN agencies (US$) in Arab World in 2000 to that in 2001?
Your answer should be very brief. 0.84. What is the ratio of the Aid flow from UN agencies (US$) of Lower middle income in 2000 to that in 2001?
Ensure brevity in your answer.  0.75. What is the ratio of the Aid flow from UN agencies (US$) of Lebanon in 2000 to that in 2001?
Make the answer very short. 1.01. What is the ratio of the Aid flow from UN agencies (US$) in Syrian Arab Republic in 2000 to that in 2001?
Your answer should be very brief. 1.04. What is the difference between the highest and the second highest Aid flow from UN agencies (US$) of Arab World?
Give a very brief answer. 5.86e+07. What is the difference between the highest and the second highest Aid flow from UN agencies (US$) in Lower middle income?
Keep it short and to the point. 5.78e+07. What is the difference between the highest and the second highest Aid flow from UN agencies (US$) in Lebanon?
Your answer should be very brief. 2.10e+05. What is the difference between the highest and the lowest Aid flow from UN agencies (US$) in Arab World?
Provide a succinct answer. 1.23e+08. What is the difference between the highest and the lowest Aid flow from UN agencies (US$) of Lower middle income?
Ensure brevity in your answer.  9.55e+07. What is the difference between the highest and the lowest Aid flow from UN agencies (US$) of Lebanon?
Keep it short and to the point. 1.29e+07. What is the difference between the highest and the lowest Aid flow from UN agencies (US$) in Syrian Arab Republic?
Provide a succinct answer. 3.68e+06. 